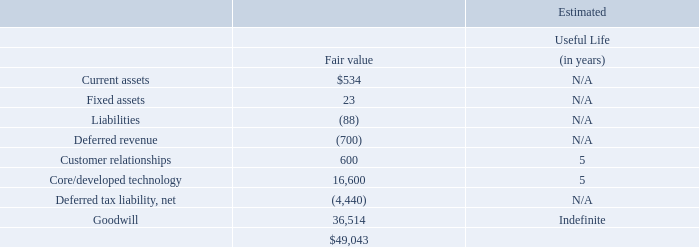WebLife Balance, Inc.
On November 30, 2017 (the “WebLife Acquisition Date”), pursuant to the terms of a merger agreement, the Company acquired all shares of WebLife Balance, Inc. (“WebLife”), a browser isolation offerings vendor, to extend its advanced threat protection capabilities into personal email, while preserving the privacy of its users.
The Company has estimated fair values of acquired tangible assets, intangible assets and liabilities at the WebLife Acquisition Date. The results of operations and the fair values of the acquired assets and liabilities assumed have been included in the accompanying consolidated financial statements since the WebLife Acquisition Date.
At the WebLife Acquisition Date, the consideration transferred was $48,765, net of cash acquired of $278.
Per the terms of the merger agreement, unvested stock options held by WebLife employees were canceled and exchanged for the Company’s unvested awards. The fair value of $333 of these unvested options was attributed to pre-combination service and included in consideration transferred. The fair value of $1,468 was allocated to post-combination services. The unvested awards are subject to the recipient’s continued service with the Company, and $1,468 is recognized ratably as stock-based compensation expense over the required remaining service period. Also, as part of the merger agreement, 107 shares of the Company’s common stock were deferred for certain key employees with the total fair value of $9,652 (see Note 11 “Equity Award Plans”), which was not included in the purchase price. The deferred shares are subject to forfeiture if employment terminates prior to the lapse of the restrictions, and their fair value is expensed as stock-based compensation expense over the remaining period.
Proofpoint, Inc. Notes to Consolidated Financial Statements (Continued) (dollars and share amounts in thousands, except per share amounts)
The following table summarizes the fair values of tangible assets acquired, liabilities assumed, intangible assets and goodwill:
What is the amount of net cash acquired at the WebLife Acquisition Date?
Answer scale should be: thousand. $278. Under what conditions were the deferred shares subjected to forfeiture? If employment terminates prior to the lapse of the restrictions, and their fair value is expensed as stock-based compensation expense over the remaining period. What is the amount of Goodwill in fair value?
Answer scale should be: thousand. 36,514. What is the difference in fair value between current assets and fixed assets?
Answer scale should be: thousand. $534 - 23
Answer: 511. What is the average fair value of Core/developed technology?
Answer scale should be: thousand. 16,600 / 5
Answer: 3320. What is the total fair value of all tangible assets?
Answer scale should be: thousand. $534 + 23
Answer: 557. 